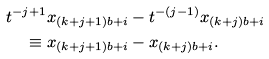<formula> <loc_0><loc_0><loc_500><loc_500>t ^ { - j + 1 } x _ { ( k + j + 1 ) b + i } & - t ^ { - ( j - 1 ) } x _ { ( k + j ) b + i } \\ \equiv x _ { ( k + j + 1 ) b + i } & - x _ { ( k + j ) b + i } .</formula> 